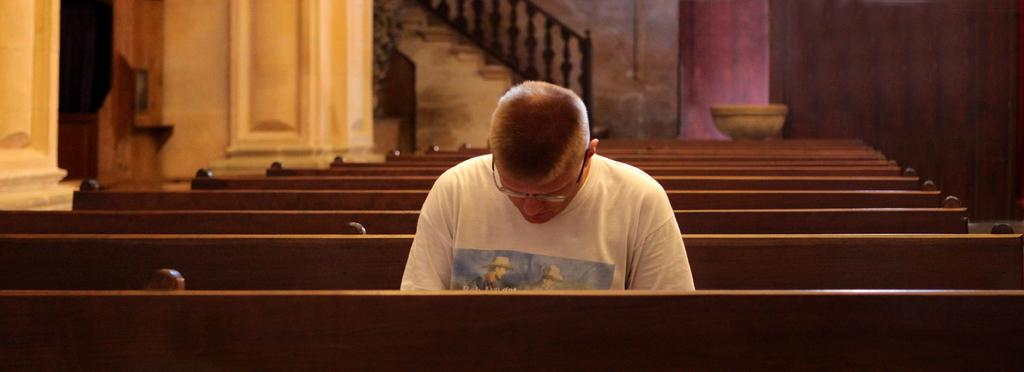Who is present in the image? There is a person in the image. What is the person wearing? The person is wearing a white T-shirt. What is the person doing in the image? The person is sitting on a bench. How many benches can be seen in the image? There are multiple benches in the image. What can be seen in the background of the image? There is a wall and a staircase in the background of the image. What type of account does the person have with the roof in the image? There is no roof or account mentioned in the image; it only features a person sitting on a bench with a wall and staircase in the background. 